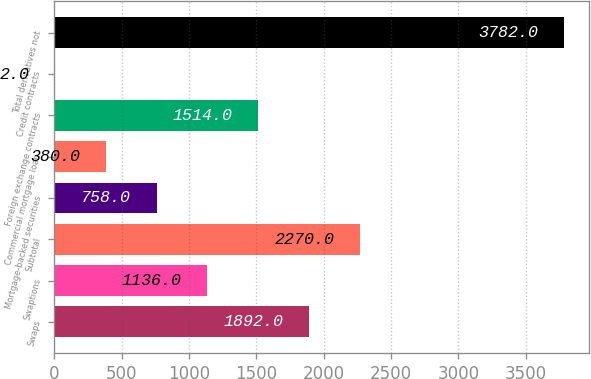<chart> <loc_0><loc_0><loc_500><loc_500><bar_chart><fcel>Swaps<fcel>Swaptions<fcel>Subtotal<fcel>Mortgage-backed securities<fcel>Commercial mortgage loan<fcel>Foreign exchange contracts<fcel>Credit contracts<fcel>Total derivatives not<nl><fcel>1892<fcel>1136<fcel>2270<fcel>758<fcel>380<fcel>1514<fcel>2<fcel>3782<nl></chart> 